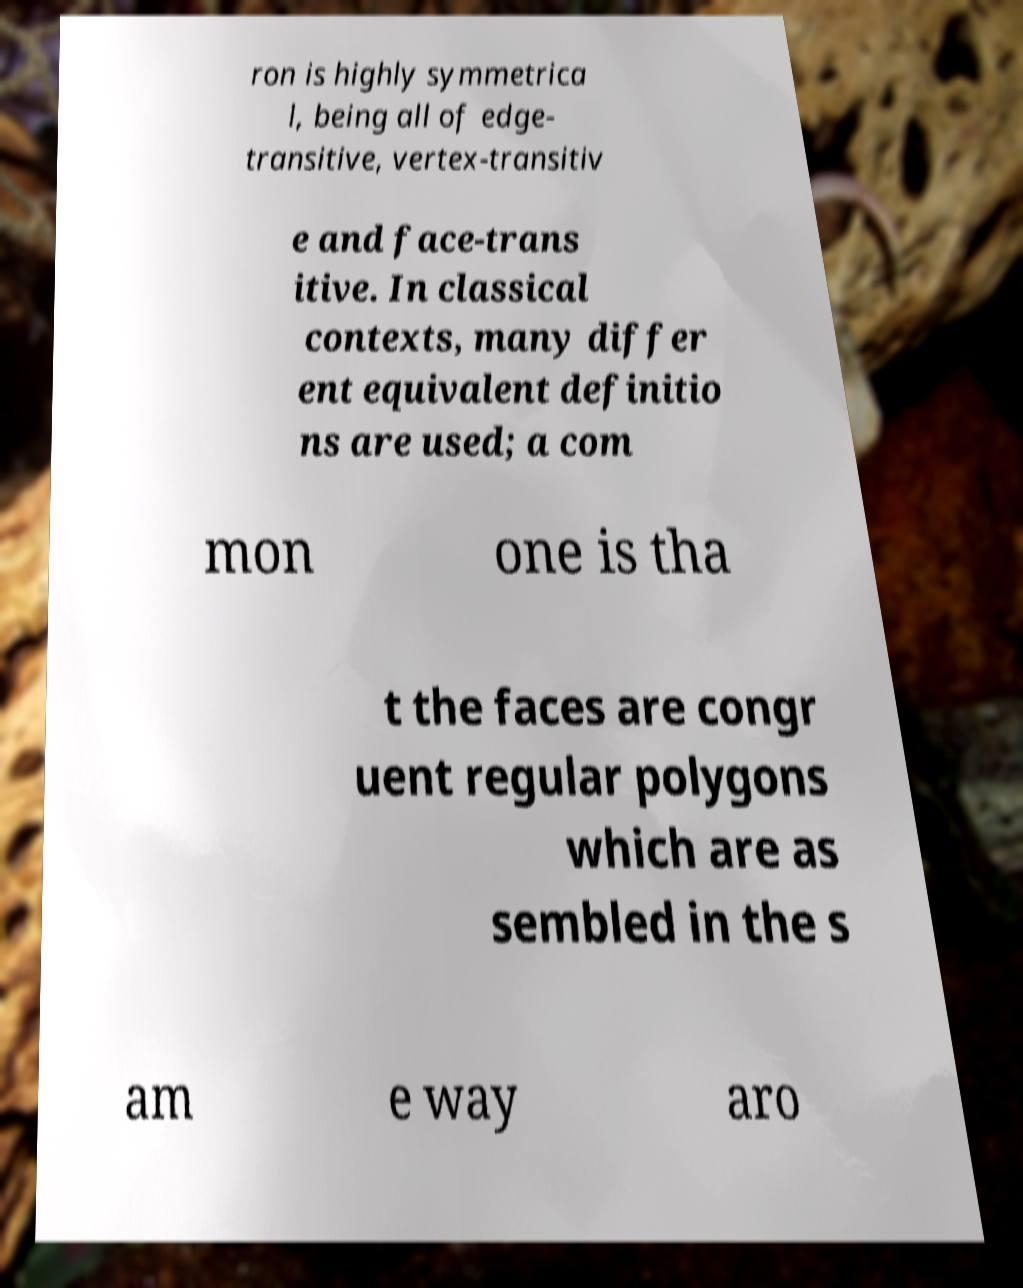Please identify and transcribe the text found in this image. ron is highly symmetrica l, being all of edge- transitive, vertex-transitiv e and face-trans itive. In classical contexts, many differ ent equivalent definitio ns are used; a com mon one is tha t the faces are congr uent regular polygons which are as sembled in the s am e way aro 